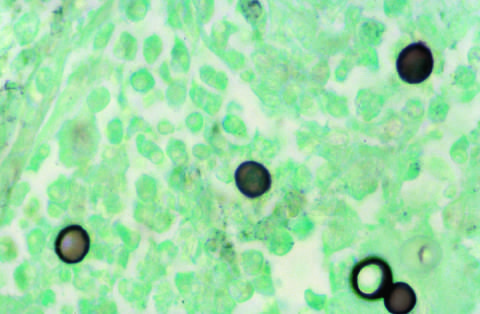does the absence of staining highlight the broad-based budding seen in blastomyces immitis organisms?
Answer the question using a single word or phrase. No 